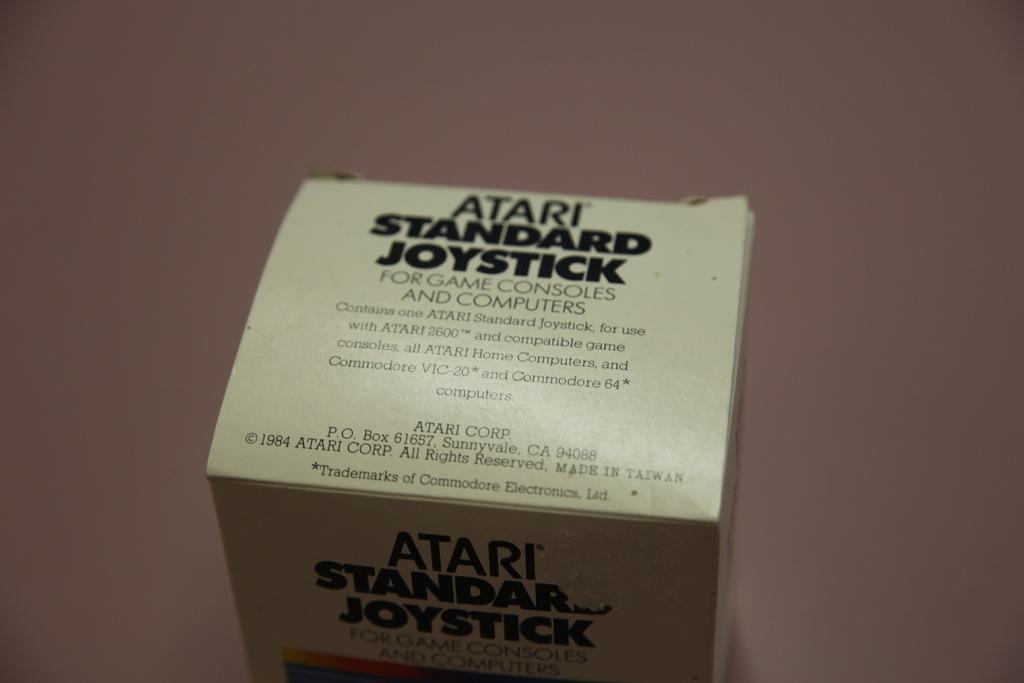Which company made this joystick?
Give a very brief answer. Atari. What atari product is this?
Your answer should be very brief. Standard joystick. 